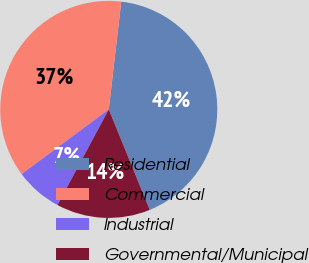Convert chart to OTSL. <chart><loc_0><loc_0><loc_500><loc_500><pie_chart><fcel>Residential<fcel>Commercial<fcel>Industrial<fcel>Governmental/Municipal<nl><fcel>42.0%<fcel>37.0%<fcel>7.0%<fcel>14.0%<nl></chart> 